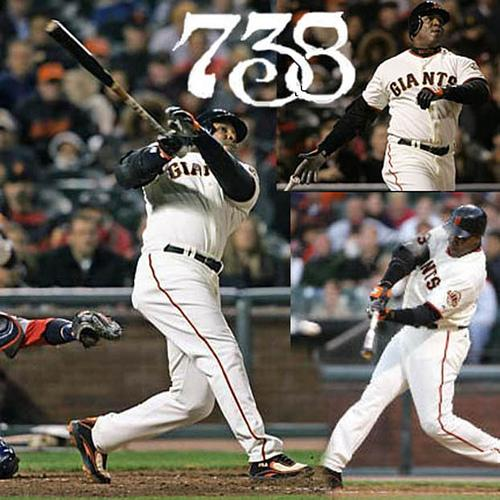What kind of helmet is the person wearing and what is its color? The person is wearing a dark, black-colored helmet. In terms of position and physical components, describe the scene behind the batter. Behind the batter is green grass, a low brick wall, a gray metal railing, and an orange panel on their gloves. Identify a prominent object in the image and provide a brief description of its color and appearance. A black sports shoe with white accents and laces, appearing to be worn by a person playing baseball. Provide a brief description of one of the tasks you would use to analyze this image. An object counting task would involve identifying and counting the number of different objects or elements present in the image, such as players, items of clothing, and accessories. What color is the baseball player's pants and which design element can be noticed on them? The baseball player's pants are white with a red stripe stitched on it. Describe briefly about the pant stripe in terms of its placement and color. The pant stripe is placed down the leg of the white pants and is red in color. Name a unique detail about the catcher's mitt and the batter's gloves. The catcher's mitt is black, and the batter's gloves have an orange panel on top. Mention any distinct accessory or gear the batter is wearing and its color. The batter is wearing black gloves and a black belt underneath a white belt loop. Describe the position and attire of the audience in the image. The crowd is sitting in the stands in the background, wearing a mix of casual clothes like shirts and pants. Explain what the person swinging a baseball bat is about to do. The person swinging a baseball bat is getting ready to hit the ball, which is white in color. Describe the objects related to the batter's pants. White pants with a red stripe, a white belt loop, and a black belt Can you locate the yellow helmet on the baseball player? There is no mention of a yellow helmet in the image. The only helmet mentioned is a black one worn by a person. Based on the image, is there a catcher's hand present in the scene, and what color is their mitt? Yes, black mitt Can you tell if the man wearing a baseball uniform is a part of this scene, based on the provided information? Yes Analyze the information to understand whether it can be used for diagram understanding tasks. No Based on the details given, detect if there is an event occurring in the scene. Yes, a baseball game event Determine what type of shoes a person in the scene is wearing according to the given details. Tennis shoes Can you find a purple stripe on the person's pants? There is no mention of a purple stripe on any pants. There is a red stripe stitched on the pants and a stripe down the leg of the pants, but there's no mention of a purple one. Can you find a person wearing a red shirt in the image? There is no mention of any person wearing a red shirt in the image, only those wearing white or black shirts. Choose the correct option for the following question: What is the color of the baseball? b) Black Identify the activity taking place in the scene as described by the given information. A person swinging a baseball bat Where is the blue baseball glove in the image? There is no mention of a blue baseball glove. The only glove mentioned is a black mitt on the catcher's hand. Where are the spectators sitting on green bleacher seats? There is no mention of green bleacher seats in the image. The crowd is sitting in the stands, but no specific color is mentioned for the seats. In a poetic style, describe the image of a person wearing a baseball glove. Oh, valiant wearer of the baseball glove, thy hand adorned in protective leathers Express the appearance of the metal railing behind the batter in an elegant manner. A gracefully constructed gray metal railing lies behind the batter. Please read and comprehend the given text to answer: What is the color of the helmet worn by the man? Black What is the color of the bat according to the information given? No color mentioned Where is the baseball player holding a yellow bat? There is no mention of a yellow bat in the image. The_person_swinging_baseball_bat object suggests that the player is holding a bat, but no specific color is mentioned. What is the color of the grass behind the batter? Green 